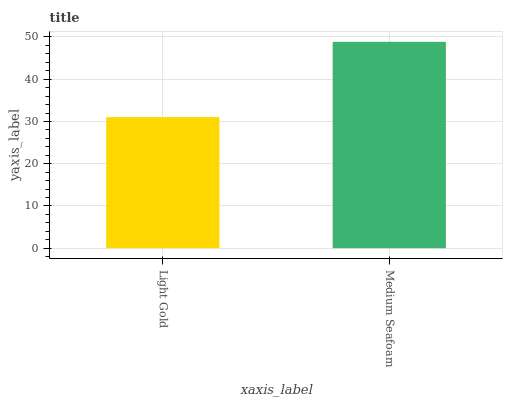Is Light Gold the minimum?
Answer yes or no. Yes. Is Medium Seafoam the maximum?
Answer yes or no. Yes. Is Medium Seafoam the minimum?
Answer yes or no. No. Is Medium Seafoam greater than Light Gold?
Answer yes or no. Yes. Is Light Gold less than Medium Seafoam?
Answer yes or no. Yes. Is Light Gold greater than Medium Seafoam?
Answer yes or no. No. Is Medium Seafoam less than Light Gold?
Answer yes or no. No. Is Medium Seafoam the high median?
Answer yes or no. Yes. Is Light Gold the low median?
Answer yes or no. Yes. Is Light Gold the high median?
Answer yes or no. No. Is Medium Seafoam the low median?
Answer yes or no. No. 